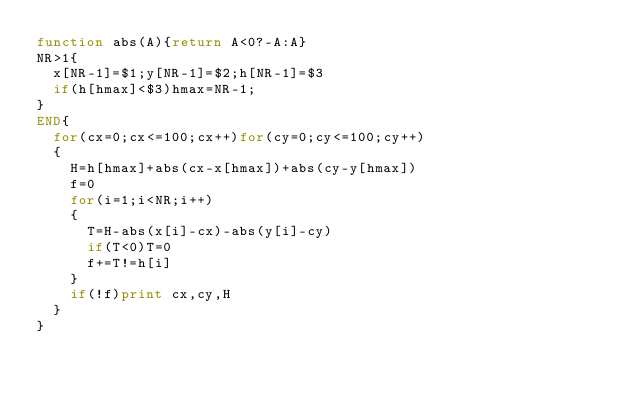<code> <loc_0><loc_0><loc_500><loc_500><_Awk_>function abs(A){return A<0?-A:A}
NR>1{
	x[NR-1]=$1;y[NR-1]=$2;h[NR-1]=$3
	if(h[hmax]<$3)hmax=NR-1;
}
END{
	for(cx=0;cx<=100;cx++)for(cy=0;cy<=100;cy++)
	{
		H=h[hmax]+abs(cx-x[hmax])+abs(cy-y[hmax])
		f=0
		for(i=1;i<NR;i++)
		{
			T=H-abs(x[i]-cx)-abs(y[i]-cy)
			if(T<0)T=0
			f+=T!=h[i]
		}
		if(!f)print cx,cy,H
	}
}</code> 